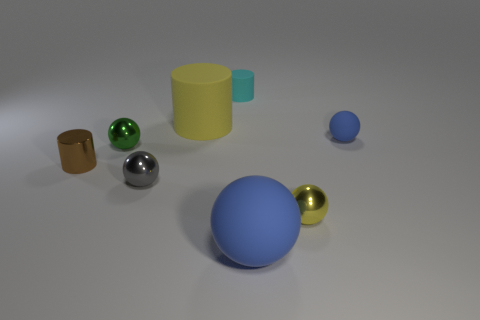There is a yellow rubber object; does it have the same size as the object that is to the left of the green metallic thing?
Provide a short and direct response. No. There is a blue thing that is behind the metallic ball behind the gray metal ball; what number of large yellow matte cylinders are behind it?
Offer a terse response. 1. What size is the thing that is the same color as the large matte cylinder?
Your response must be concise. Small. Are there any objects behind the large blue matte thing?
Offer a very short reply. Yes. There is a tiny blue thing; what shape is it?
Offer a very short reply. Sphere. What shape is the yellow object to the left of the yellow object to the right of the small cylinder on the right side of the shiny cylinder?
Your response must be concise. Cylinder. How many other objects are there of the same shape as the green metal object?
Keep it short and to the point. 4. What is the material of the blue sphere that is behind the small metal sphere that is behind the brown metal thing?
Provide a succinct answer. Rubber. Is the small cyan object made of the same material as the blue thing behind the tiny green metal thing?
Provide a short and direct response. Yes. What is the ball that is both in front of the gray metal object and behind the large blue object made of?
Provide a short and direct response. Metal. 